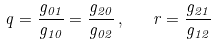Convert formula to latex. <formula><loc_0><loc_0><loc_500><loc_500>q = \frac { g _ { 0 1 } } { g _ { 1 0 } } = \frac { g _ { 2 0 } } { g _ { 0 2 } } \, , \quad r = \frac { g _ { 2 1 } } { g _ { 1 2 } }</formula> 